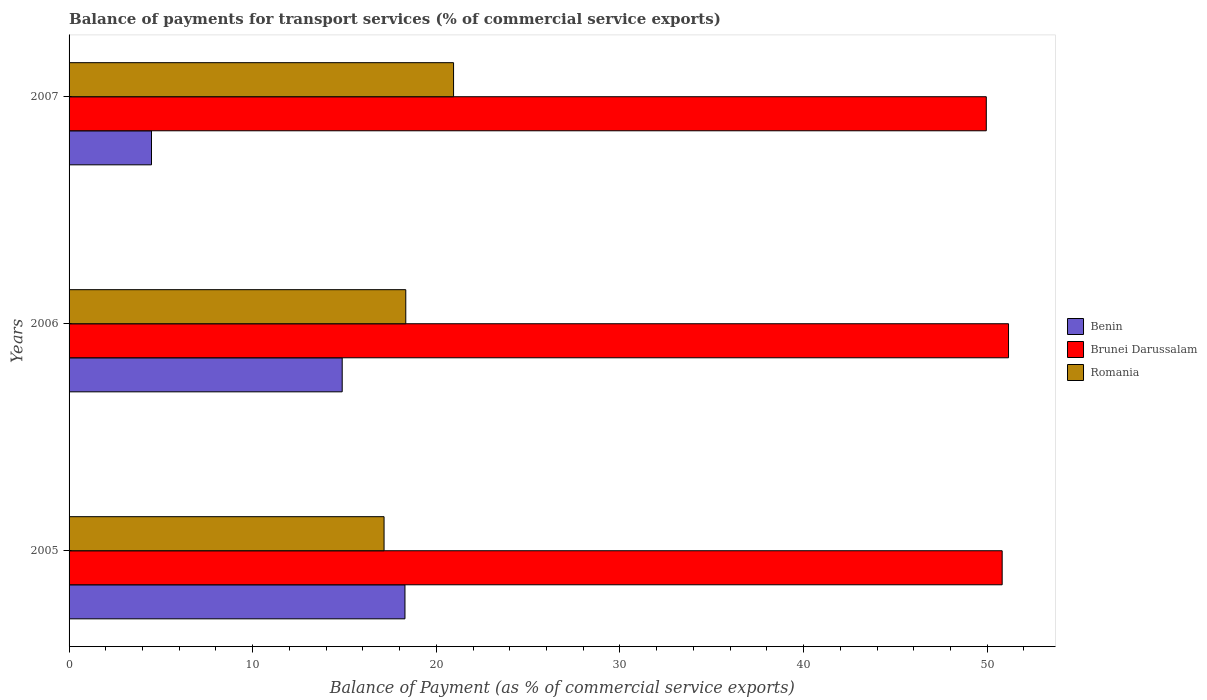Are the number of bars per tick equal to the number of legend labels?
Keep it short and to the point. Yes. How many bars are there on the 2nd tick from the top?
Provide a succinct answer. 3. How many bars are there on the 3rd tick from the bottom?
Your answer should be compact. 3. What is the label of the 2nd group of bars from the top?
Your answer should be very brief. 2006. In how many cases, is the number of bars for a given year not equal to the number of legend labels?
Provide a succinct answer. 0. What is the balance of payments for transport services in Romania in 2007?
Your answer should be very brief. 20.94. Across all years, what is the maximum balance of payments for transport services in Benin?
Your answer should be compact. 18.29. Across all years, what is the minimum balance of payments for transport services in Brunei Darussalam?
Your answer should be very brief. 49.95. In which year was the balance of payments for transport services in Brunei Darussalam maximum?
Provide a short and direct response. 2006. In which year was the balance of payments for transport services in Brunei Darussalam minimum?
Keep it short and to the point. 2007. What is the total balance of payments for transport services in Romania in the graph?
Offer a very short reply. 56.43. What is the difference between the balance of payments for transport services in Brunei Darussalam in 2005 and that in 2007?
Your answer should be very brief. 0.86. What is the difference between the balance of payments for transport services in Benin in 2006 and the balance of payments for transport services in Romania in 2005?
Give a very brief answer. -2.28. What is the average balance of payments for transport services in Romania per year?
Your answer should be compact. 18.81. In the year 2006, what is the difference between the balance of payments for transport services in Benin and balance of payments for transport services in Romania?
Your response must be concise. -3.46. What is the ratio of the balance of payments for transport services in Brunei Darussalam in 2005 to that in 2006?
Your answer should be very brief. 0.99. Is the difference between the balance of payments for transport services in Benin in 2005 and 2007 greater than the difference between the balance of payments for transport services in Romania in 2005 and 2007?
Keep it short and to the point. Yes. What is the difference between the highest and the second highest balance of payments for transport services in Brunei Darussalam?
Your answer should be compact. 0.35. What is the difference between the highest and the lowest balance of payments for transport services in Benin?
Provide a succinct answer. 13.8. In how many years, is the balance of payments for transport services in Benin greater than the average balance of payments for transport services in Benin taken over all years?
Provide a succinct answer. 2. Is the sum of the balance of payments for transport services in Brunei Darussalam in 2005 and 2007 greater than the maximum balance of payments for transport services in Benin across all years?
Offer a terse response. Yes. What does the 2nd bar from the top in 2006 represents?
Provide a succinct answer. Brunei Darussalam. What does the 3rd bar from the bottom in 2005 represents?
Offer a terse response. Romania. How many bars are there?
Your answer should be compact. 9. What is the difference between two consecutive major ticks on the X-axis?
Provide a succinct answer. 10. Are the values on the major ticks of X-axis written in scientific E-notation?
Your response must be concise. No. Does the graph contain any zero values?
Offer a terse response. No. How are the legend labels stacked?
Your answer should be compact. Vertical. What is the title of the graph?
Provide a short and direct response. Balance of payments for transport services (% of commercial service exports). What is the label or title of the X-axis?
Give a very brief answer. Balance of Payment (as % of commercial service exports). What is the label or title of the Y-axis?
Your answer should be compact. Years. What is the Balance of Payment (as % of commercial service exports) in Benin in 2005?
Give a very brief answer. 18.29. What is the Balance of Payment (as % of commercial service exports) of Brunei Darussalam in 2005?
Offer a very short reply. 50.81. What is the Balance of Payment (as % of commercial service exports) in Romania in 2005?
Your response must be concise. 17.15. What is the Balance of Payment (as % of commercial service exports) of Benin in 2006?
Provide a succinct answer. 14.87. What is the Balance of Payment (as % of commercial service exports) of Brunei Darussalam in 2006?
Ensure brevity in your answer.  51.16. What is the Balance of Payment (as % of commercial service exports) of Romania in 2006?
Provide a succinct answer. 18.34. What is the Balance of Payment (as % of commercial service exports) of Benin in 2007?
Keep it short and to the point. 4.49. What is the Balance of Payment (as % of commercial service exports) of Brunei Darussalam in 2007?
Ensure brevity in your answer.  49.95. What is the Balance of Payment (as % of commercial service exports) in Romania in 2007?
Make the answer very short. 20.94. Across all years, what is the maximum Balance of Payment (as % of commercial service exports) of Benin?
Give a very brief answer. 18.29. Across all years, what is the maximum Balance of Payment (as % of commercial service exports) in Brunei Darussalam?
Offer a terse response. 51.16. Across all years, what is the maximum Balance of Payment (as % of commercial service exports) of Romania?
Make the answer very short. 20.94. Across all years, what is the minimum Balance of Payment (as % of commercial service exports) in Benin?
Your response must be concise. 4.49. Across all years, what is the minimum Balance of Payment (as % of commercial service exports) of Brunei Darussalam?
Your answer should be very brief. 49.95. Across all years, what is the minimum Balance of Payment (as % of commercial service exports) of Romania?
Offer a terse response. 17.15. What is the total Balance of Payment (as % of commercial service exports) of Benin in the graph?
Give a very brief answer. 37.66. What is the total Balance of Payment (as % of commercial service exports) of Brunei Darussalam in the graph?
Offer a very short reply. 151.92. What is the total Balance of Payment (as % of commercial service exports) in Romania in the graph?
Your answer should be compact. 56.43. What is the difference between the Balance of Payment (as % of commercial service exports) of Benin in 2005 and that in 2006?
Your response must be concise. 3.42. What is the difference between the Balance of Payment (as % of commercial service exports) of Brunei Darussalam in 2005 and that in 2006?
Provide a succinct answer. -0.35. What is the difference between the Balance of Payment (as % of commercial service exports) in Romania in 2005 and that in 2006?
Make the answer very short. -1.18. What is the difference between the Balance of Payment (as % of commercial service exports) of Benin in 2005 and that in 2007?
Make the answer very short. 13.8. What is the difference between the Balance of Payment (as % of commercial service exports) in Brunei Darussalam in 2005 and that in 2007?
Keep it short and to the point. 0.86. What is the difference between the Balance of Payment (as % of commercial service exports) in Romania in 2005 and that in 2007?
Your response must be concise. -3.78. What is the difference between the Balance of Payment (as % of commercial service exports) of Benin in 2006 and that in 2007?
Offer a terse response. 10.38. What is the difference between the Balance of Payment (as % of commercial service exports) of Brunei Darussalam in 2006 and that in 2007?
Make the answer very short. 1.21. What is the difference between the Balance of Payment (as % of commercial service exports) in Romania in 2006 and that in 2007?
Keep it short and to the point. -2.6. What is the difference between the Balance of Payment (as % of commercial service exports) of Benin in 2005 and the Balance of Payment (as % of commercial service exports) of Brunei Darussalam in 2006?
Provide a succinct answer. -32.87. What is the difference between the Balance of Payment (as % of commercial service exports) in Benin in 2005 and the Balance of Payment (as % of commercial service exports) in Romania in 2006?
Keep it short and to the point. -0.04. What is the difference between the Balance of Payment (as % of commercial service exports) of Brunei Darussalam in 2005 and the Balance of Payment (as % of commercial service exports) of Romania in 2006?
Keep it short and to the point. 32.48. What is the difference between the Balance of Payment (as % of commercial service exports) of Benin in 2005 and the Balance of Payment (as % of commercial service exports) of Brunei Darussalam in 2007?
Offer a terse response. -31.66. What is the difference between the Balance of Payment (as % of commercial service exports) of Benin in 2005 and the Balance of Payment (as % of commercial service exports) of Romania in 2007?
Keep it short and to the point. -2.65. What is the difference between the Balance of Payment (as % of commercial service exports) in Brunei Darussalam in 2005 and the Balance of Payment (as % of commercial service exports) in Romania in 2007?
Offer a terse response. 29.88. What is the difference between the Balance of Payment (as % of commercial service exports) in Benin in 2006 and the Balance of Payment (as % of commercial service exports) in Brunei Darussalam in 2007?
Give a very brief answer. -35.08. What is the difference between the Balance of Payment (as % of commercial service exports) in Benin in 2006 and the Balance of Payment (as % of commercial service exports) in Romania in 2007?
Make the answer very short. -6.06. What is the difference between the Balance of Payment (as % of commercial service exports) of Brunei Darussalam in 2006 and the Balance of Payment (as % of commercial service exports) of Romania in 2007?
Make the answer very short. 30.22. What is the average Balance of Payment (as % of commercial service exports) in Benin per year?
Offer a terse response. 12.55. What is the average Balance of Payment (as % of commercial service exports) in Brunei Darussalam per year?
Provide a succinct answer. 50.64. What is the average Balance of Payment (as % of commercial service exports) of Romania per year?
Provide a short and direct response. 18.81. In the year 2005, what is the difference between the Balance of Payment (as % of commercial service exports) of Benin and Balance of Payment (as % of commercial service exports) of Brunei Darussalam?
Give a very brief answer. -32.52. In the year 2005, what is the difference between the Balance of Payment (as % of commercial service exports) of Benin and Balance of Payment (as % of commercial service exports) of Romania?
Your response must be concise. 1.14. In the year 2005, what is the difference between the Balance of Payment (as % of commercial service exports) of Brunei Darussalam and Balance of Payment (as % of commercial service exports) of Romania?
Your answer should be very brief. 33.66. In the year 2006, what is the difference between the Balance of Payment (as % of commercial service exports) in Benin and Balance of Payment (as % of commercial service exports) in Brunei Darussalam?
Your answer should be very brief. -36.29. In the year 2006, what is the difference between the Balance of Payment (as % of commercial service exports) of Benin and Balance of Payment (as % of commercial service exports) of Romania?
Your answer should be compact. -3.46. In the year 2006, what is the difference between the Balance of Payment (as % of commercial service exports) of Brunei Darussalam and Balance of Payment (as % of commercial service exports) of Romania?
Make the answer very short. 32.82. In the year 2007, what is the difference between the Balance of Payment (as % of commercial service exports) of Benin and Balance of Payment (as % of commercial service exports) of Brunei Darussalam?
Your answer should be compact. -45.46. In the year 2007, what is the difference between the Balance of Payment (as % of commercial service exports) of Benin and Balance of Payment (as % of commercial service exports) of Romania?
Make the answer very short. -16.45. In the year 2007, what is the difference between the Balance of Payment (as % of commercial service exports) of Brunei Darussalam and Balance of Payment (as % of commercial service exports) of Romania?
Provide a short and direct response. 29.01. What is the ratio of the Balance of Payment (as % of commercial service exports) in Benin in 2005 to that in 2006?
Your answer should be very brief. 1.23. What is the ratio of the Balance of Payment (as % of commercial service exports) in Romania in 2005 to that in 2006?
Offer a very short reply. 0.94. What is the ratio of the Balance of Payment (as % of commercial service exports) of Benin in 2005 to that in 2007?
Keep it short and to the point. 4.07. What is the ratio of the Balance of Payment (as % of commercial service exports) in Brunei Darussalam in 2005 to that in 2007?
Your answer should be compact. 1.02. What is the ratio of the Balance of Payment (as % of commercial service exports) in Romania in 2005 to that in 2007?
Give a very brief answer. 0.82. What is the ratio of the Balance of Payment (as % of commercial service exports) in Benin in 2006 to that in 2007?
Ensure brevity in your answer.  3.31. What is the ratio of the Balance of Payment (as % of commercial service exports) in Brunei Darussalam in 2006 to that in 2007?
Your answer should be very brief. 1.02. What is the ratio of the Balance of Payment (as % of commercial service exports) of Romania in 2006 to that in 2007?
Make the answer very short. 0.88. What is the difference between the highest and the second highest Balance of Payment (as % of commercial service exports) in Benin?
Give a very brief answer. 3.42. What is the difference between the highest and the second highest Balance of Payment (as % of commercial service exports) of Brunei Darussalam?
Provide a succinct answer. 0.35. What is the difference between the highest and the second highest Balance of Payment (as % of commercial service exports) in Romania?
Offer a very short reply. 2.6. What is the difference between the highest and the lowest Balance of Payment (as % of commercial service exports) in Benin?
Keep it short and to the point. 13.8. What is the difference between the highest and the lowest Balance of Payment (as % of commercial service exports) of Brunei Darussalam?
Ensure brevity in your answer.  1.21. What is the difference between the highest and the lowest Balance of Payment (as % of commercial service exports) in Romania?
Your answer should be compact. 3.78. 